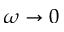Convert formula to latex. <formula><loc_0><loc_0><loc_500><loc_500>\omega \to 0</formula> 